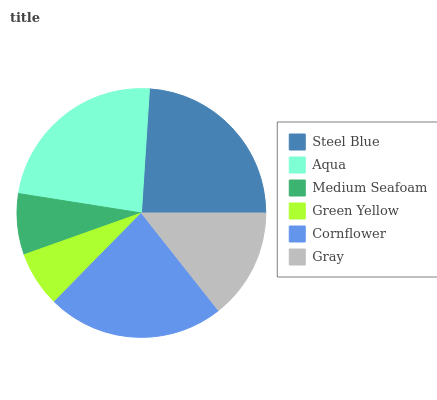Is Green Yellow the minimum?
Answer yes or no. Yes. Is Steel Blue the maximum?
Answer yes or no. Yes. Is Aqua the minimum?
Answer yes or no. No. Is Aqua the maximum?
Answer yes or no. No. Is Steel Blue greater than Aqua?
Answer yes or no. Yes. Is Aqua less than Steel Blue?
Answer yes or no. Yes. Is Aqua greater than Steel Blue?
Answer yes or no. No. Is Steel Blue less than Aqua?
Answer yes or no. No. Is Cornflower the high median?
Answer yes or no. Yes. Is Gray the low median?
Answer yes or no. Yes. Is Aqua the high median?
Answer yes or no. No. Is Medium Seafoam the low median?
Answer yes or no. No. 